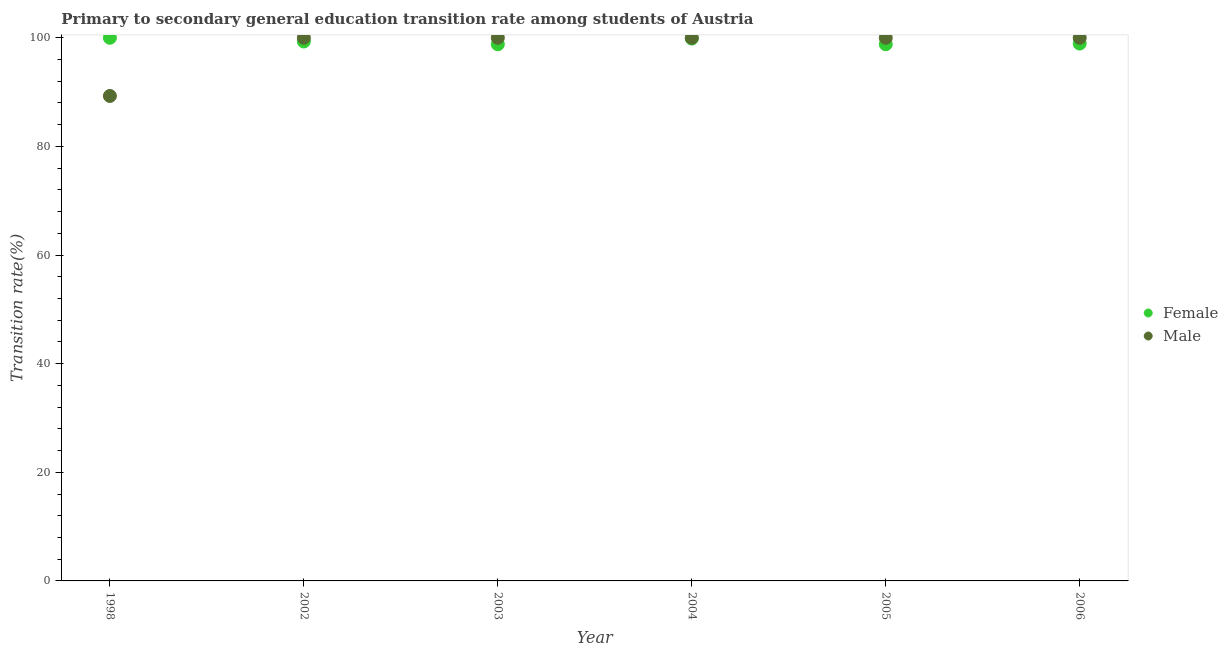Is the number of dotlines equal to the number of legend labels?
Make the answer very short. Yes. Across all years, what is the minimum transition rate among male students?
Your answer should be very brief. 89.29. What is the total transition rate among male students in the graph?
Offer a terse response. 589.29. What is the difference between the transition rate among male students in 2003 and that in 2005?
Provide a succinct answer. 0. What is the difference between the transition rate among male students in 2006 and the transition rate among female students in 2005?
Your response must be concise. 1.19. What is the average transition rate among female students per year?
Provide a short and direct response. 99.29. In the year 2003, what is the difference between the transition rate among male students and transition rate among female students?
Ensure brevity in your answer.  1.2. In how many years, is the transition rate among male students greater than 36 %?
Make the answer very short. 6. What is the ratio of the transition rate among female students in 1998 to that in 2005?
Your answer should be compact. 1.01. Is the transition rate among male students in 1998 less than that in 2002?
Ensure brevity in your answer.  Yes. Is the difference between the transition rate among female students in 1998 and 2003 greater than the difference between the transition rate among male students in 1998 and 2003?
Ensure brevity in your answer.  Yes. What is the difference between the highest and the second highest transition rate among male students?
Ensure brevity in your answer.  0. What is the difference between the highest and the lowest transition rate among male students?
Your response must be concise. 10.71. Is the sum of the transition rate among female students in 1998 and 2003 greater than the maximum transition rate among male students across all years?
Your response must be concise. Yes. Does the transition rate among male students monotonically increase over the years?
Provide a short and direct response. No. How many dotlines are there?
Provide a succinct answer. 2. How many years are there in the graph?
Offer a very short reply. 6. What is the difference between two consecutive major ticks on the Y-axis?
Give a very brief answer. 20. Are the values on the major ticks of Y-axis written in scientific E-notation?
Keep it short and to the point. No. Does the graph contain any zero values?
Your answer should be very brief. No. How are the legend labels stacked?
Keep it short and to the point. Vertical. What is the title of the graph?
Provide a short and direct response. Primary to secondary general education transition rate among students of Austria. Does "Pregnant women" appear as one of the legend labels in the graph?
Your answer should be compact. No. What is the label or title of the X-axis?
Your answer should be very brief. Year. What is the label or title of the Y-axis?
Give a very brief answer. Transition rate(%). What is the Transition rate(%) of Female in 1998?
Your response must be concise. 100. What is the Transition rate(%) of Male in 1998?
Your response must be concise. 89.29. What is the Transition rate(%) in Female in 2002?
Provide a short and direct response. 99.32. What is the Transition rate(%) in Male in 2002?
Offer a terse response. 100. What is the Transition rate(%) of Female in 2003?
Provide a succinct answer. 98.8. What is the Transition rate(%) in Male in 2003?
Offer a very short reply. 100. What is the Transition rate(%) of Female in 2004?
Offer a very short reply. 99.85. What is the Transition rate(%) of Male in 2004?
Ensure brevity in your answer.  100. What is the Transition rate(%) of Female in 2005?
Make the answer very short. 98.81. What is the Transition rate(%) in Female in 2006?
Your response must be concise. 98.94. Across all years, what is the maximum Transition rate(%) of Female?
Offer a very short reply. 100. Across all years, what is the maximum Transition rate(%) of Male?
Ensure brevity in your answer.  100. Across all years, what is the minimum Transition rate(%) of Female?
Give a very brief answer. 98.8. Across all years, what is the minimum Transition rate(%) of Male?
Your answer should be very brief. 89.29. What is the total Transition rate(%) in Female in the graph?
Your response must be concise. 595.72. What is the total Transition rate(%) of Male in the graph?
Make the answer very short. 589.29. What is the difference between the Transition rate(%) in Female in 1998 and that in 2002?
Your answer should be compact. 0.68. What is the difference between the Transition rate(%) of Male in 1998 and that in 2002?
Your response must be concise. -10.71. What is the difference between the Transition rate(%) of Female in 1998 and that in 2003?
Your response must be concise. 1.2. What is the difference between the Transition rate(%) of Male in 1998 and that in 2003?
Offer a very short reply. -10.71. What is the difference between the Transition rate(%) in Female in 1998 and that in 2004?
Provide a short and direct response. 0.15. What is the difference between the Transition rate(%) of Male in 1998 and that in 2004?
Your response must be concise. -10.71. What is the difference between the Transition rate(%) of Female in 1998 and that in 2005?
Give a very brief answer. 1.19. What is the difference between the Transition rate(%) in Male in 1998 and that in 2005?
Your answer should be compact. -10.71. What is the difference between the Transition rate(%) of Female in 1998 and that in 2006?
Ensure brevity in your answer.  1.06. What is the difference between the Transition rate(%) of Male in 1998 and that in 2006?
Provide a short and direct response. -10.71. What is the difference between the Transition rate(%) in Female in 2002 and that in 2003?
Your answer should be very brief. 0.52. What is the difference between the Transition rate(%) of Female in 2002 and that in 2004?
Ensure brevity in your answer.  -0.54. What is the difference between the Transition rate(%) in Female in 2002 and that in 2005?
Your answer should be compact. 0.51. What is the difference between the Transition rate(%) in Female in 2002 and that in 2006?
Ensure brevity in your answer.  0.38. What is the difference between the Transition rate(%) of Male in 2002 and that in 2006?
Offer a very short reply. 0. What is the difference between the Transition rate(%) in Female in 2003 and that in 2004?
Keep it short and to the point. -1.05. What is the difference between the Transition rate(%) of Male in 2003 and that in 2004?
Give a very brief answer. 0. What is the difference between the Transition rate(%) of Female in 2003 and that in 2005?
Your response must be concise. -0.01. What is the difference between the Transition rate(%) in Female in 2003 and that in 2006?
Provide a succinct answer. -0.14. What is the difference between the Transition rate(%) of Female in 2004 and that in 2005?
Provide a short and direct response. 1.05. What is the difference between the Transition rate(%) of Male in 2004 and that in 2005?
Provide a short and direct response. 0. What is the difference between the Transition rate(%) of Female in 2004 and that in 2006?
Keep it short and to the point. 0.92. What is the difference between the Transition rate(%) in Male in 2004 and that in 2006?
Your answer should be very brief. 0. What is the difference between the Transition rate(%) in Female in 2005 and that in 2006?
Your response must be concise. -0.13. What is the difference between the Transition rate(%) in Male in 2005 and that in 2006?
Your response must be concise. 0. What is the difference between the Transition rate(%) in Female in 1998 and the Transition rate(%) in Male in 2002?
Offer a very short reply. 0. What is the difference between the Transition rate(%) in Female in 1998 and the Transition rate(%) in Male in 2004?
Keep it short and to the point. 0. What is the difference between the Transition rate(%) in Female in 1998 and the Transition rate(%) in Male in 2005?
Offer a terse response. 0. What is the difference between the Transition rate(%) of Female in 1998 and the Transition rate(%) of Male in 2006?
Your answer should be compact. 0. What is the difference between the Transition rate(%) in Female in 2002 and the Transition rate(%) in Male in 2003?
Make the answer very short. -0.68. What is the difference between the Transition rate(%) in Female in 2002 and the Transition rate(%) in Male in 2004?
Offer a terse response. -0.68. What is the difference between the Transition rate(%) in Female in 2002 and the Transition rate(%) in Male in 2005?
Give a very brief answer. -0.68. What is the difference between the Transition rate(%) of Female in 2002 and the Transition rate(%) of Male in 2006?
Provide a short and direct response. -0.68. What is the difference between the Transition rate(%) in Female in 2003 and the Transition rate(%) in Male in 2004?
Make the answer very short. -1.2. What is the difference between the Transition rate(%) in Female in 2003 and the Transition rate(%) in Male in 2005?
Make the answer very short. -1.2. What is the difference between the Transition rate(%) in Female in 2003 and the Transition rate(%) in Male in 2006?
Your answer should be very brief. -1.2. What is the difference between the Transition rate(%) in Female in 2004 and the Transition rate(%) in Male in 2005?
Provide a short and direct response. -0.15. What is the difference between the Transition rate(%) of Female in 2004 and the Transition rate(%) of Male in 2006?
Provide a short and direct response. -0.15. What is the difference between the Transition rate(%) in Female in 2005 and the Transition rate(%) in Male in 2006?
Your answer should be compact. -1.19. What is the average Transition rate(%) of Female per year?
Your answer should be compact. 99.29. What is the average Transition rate(%) in Male per year?
Offer a terse response. 98.21. In the year 1998, what is the difference between the Transition rate(%) in Female and Transition rate(%) in Male?
Give a very brief answer. 10.71. In the year 2002, what is the difference between the Transition rate(%) of Female and Transition rate(%) of Male?
Offer a terse response. -0.68. In the year 2003, what is the difference between the Transition rate(%) in Female and Transition rate(%) in Male?
Offer a very short reply. -1.2. In the year 2004, what is the difference between the Transition rate(%) of Female and Transition rate(%) of Male?
Provide a short and direct response. -0.15. In the year 2005, what is the difference between the Transition rate(%) in Female and Transition rate(%) in Male?
Ensure brevity in your answer.  -1.19. In the year 2006, what is the difference between the Transition rate(%) of Female and Transition rate(%) of Male?
Ensure brevity in your answer.  -1.06. What is the ratio of the Transition rate(%) in Male in 1998 to that in 2002?
Give a very brief answer. 0.89. What is the ratio of the Transition rate(%) of Female in 1998 to that in 2003?
Make the answer very short. 1.01. What is the ratio of the Transition rate(%) of Male in 1998 to that in 2003?
Keep it short and to the point. 0.89. What is the ratio of the Transition rate(%) of Male in 1998 to that in 2004?
Your answer should be very brief. 0.89. What is the ratio of the Transition rate(%) in Female in 1998 to that in 2005?
Provide a short and direct response. 1.01. What is the ratio of the Transition rate(%) in Male in 1998 to that in 2005?
Offer a terse response. 0.89. What is the ratio of the Transition rate(%) in Female in 1998 to that in 2006?
Offer a terse response. 1.01. What is the ratio of the Transition rate(%) of Male in 1998 to that in 2006?
Make the answer very short. 0.89. What is the ratio of the Transition rate(%) of Male in 2002 to that in 2005?
Offer a very short reply. 1. What is the ratio of the Transition rate(%) of Female in 2002 to that in 2006?
Make the answer very short. 1. What is the ratio of the Transition rate(%) of Male in 2002 to that in 2006?
Your response must be concise. 1. What is the ratio of the Transition rate(%) of Male in 2003 to that in 2006?
Provide a succinct answer. 1. What is the ratio of the Transition rate(%) in Female in 2004 to that in 2005?
Your answer should be compact. 1.01. What is the ratio of the Transition rate(%) of Male in 2004 to that in 2005?
Provide a succinct answer. 1. What is the ratio of the Transition rate(%) of Female in 2004 to that in 2006?
Provide a succinct answer. 1.01. What is the ratio of the Transition rate(%) in Male in 2004 to that in 2006?
Give a very brief answer. 1. What is the ratio of the Transition rate(%) of Male in 2005 to that in 2006?
Offer a terse response. 1. What is the difference between the highest and the second highest Transition rate(%) of Female?
Give a very brief answer. 0.15. What is the difference between the highest and the second highest Transition rate(%) in Male?
Offer a very short reply. 0. What is the difference between the highest and the lowest Transition rate(%) in Female?
Provide a succinct answer. 1.2. What is the difference between the highest and the lowest Transition rate(%) of Male?
Keep it short and to the point. 10.71. 